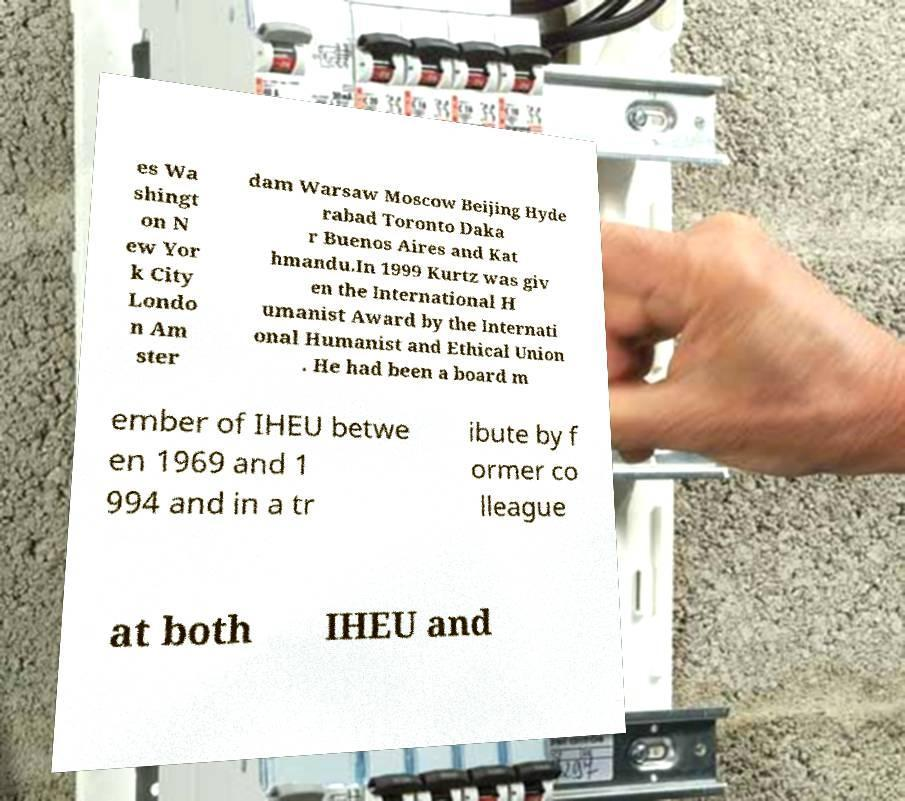Can you read and provide the text displayed in the image?This photo seems to have some interesting text. Can you extract and type it out for me? es Wa shingt on N ew Yor k City Londo n Am ster dam Warsaw Moscow Beijing Hyde rabad Toronto Daka r Buenos Aires and Kat hmandu.In 1999 Kurtz was giv en the International H umanist Award by the Internati onal Humanist and Ethical Union . He had been a board m ember of IHEU betwe en 1969 and 1 994 and in a tr ibute by f ormer co lleague at both IHEU and 